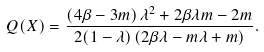Convert formula to latex. <formula><loc_0><loc_0><loc_500><loc_500>Q ( X ) = \frac { \left ( 4 \beta - 3 m \right ) \lambda ^ { 2 } + 2 \beta \lambda m - 2 m } { 2 ( 1 - \lambda ) \left ( 2 \beta \lambda - m \lambda + m \right ) } .</formula> 